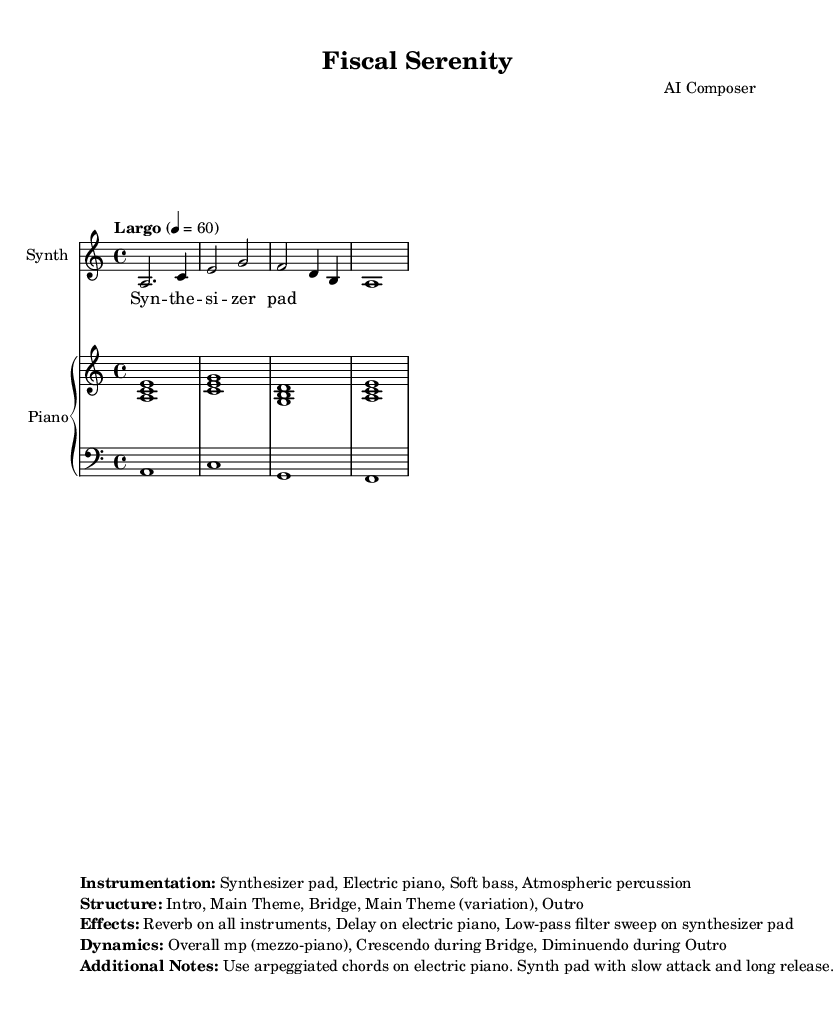What is the key signature of this music? The key signature is A minor, which has no sharps or flats. This is observed at the beginning of the sheet music where the key is indicated.
Answer: A minor What is the time signature of the piece? The time signature is 4/4, which can be found at the beginning of the score. It indicates there are four beats in each measure.
Answer: 4/4 What is the tempo marking used in the score? The tempo marking is "Largo," which is indicated in the score along with a specific metronome marking of 60 beats per minute. This suggests a slow and broad tempo.
Answer: Largo What instruments are used in this piece? The score lists Synthesizer pad, Electric piano, and Soft bass, which are clearly specified in the instrumentation section at the end of the sheet music.
Answer: Synthesizer pad, Electric piano, Soft bass How many main thematic sections are in the structure of the piece? The structure includes an Intro, Main Theme, Bridge, Main Theme (variation), and Outro. By counting these sections, we find there are five thematic sections in total.
Answer: Five What dynamics are indicated for this piece? The score states that the overall dynamics should be mp (mezzo-piano) with a crescendo during the Bridge and diminuendo during the Outro, which is explicitly mentioned in the additional notes at the end of the sheet music.
Answer: mp (mezzo-piano) 